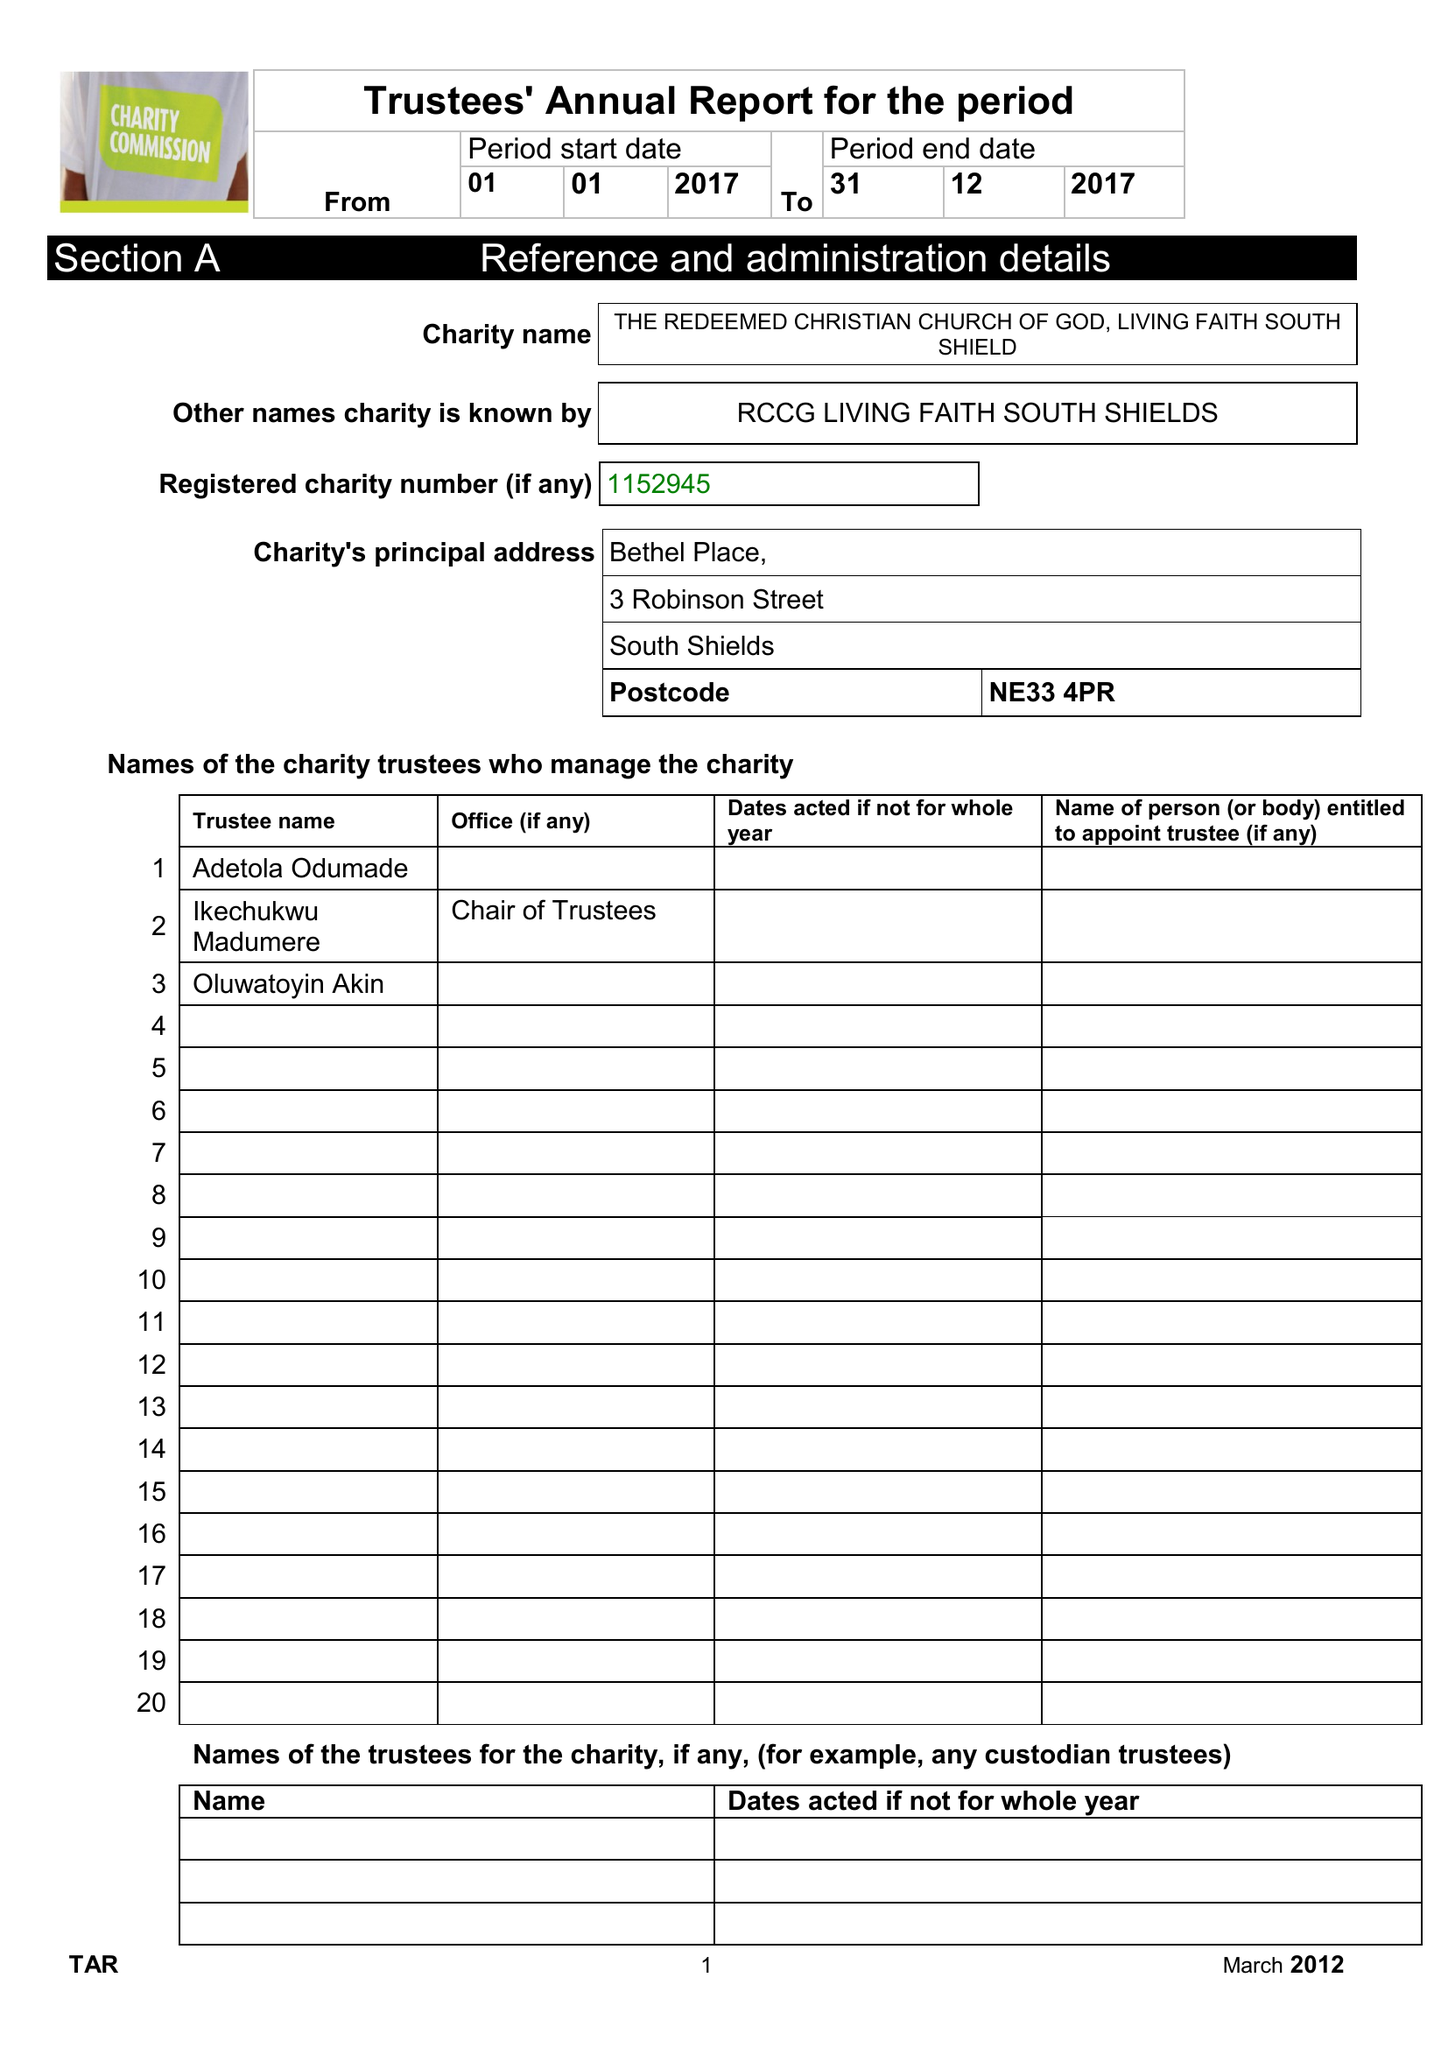What is the value for the address__postcode?
Answer the question using a single word or phrase. NE33 4PR 